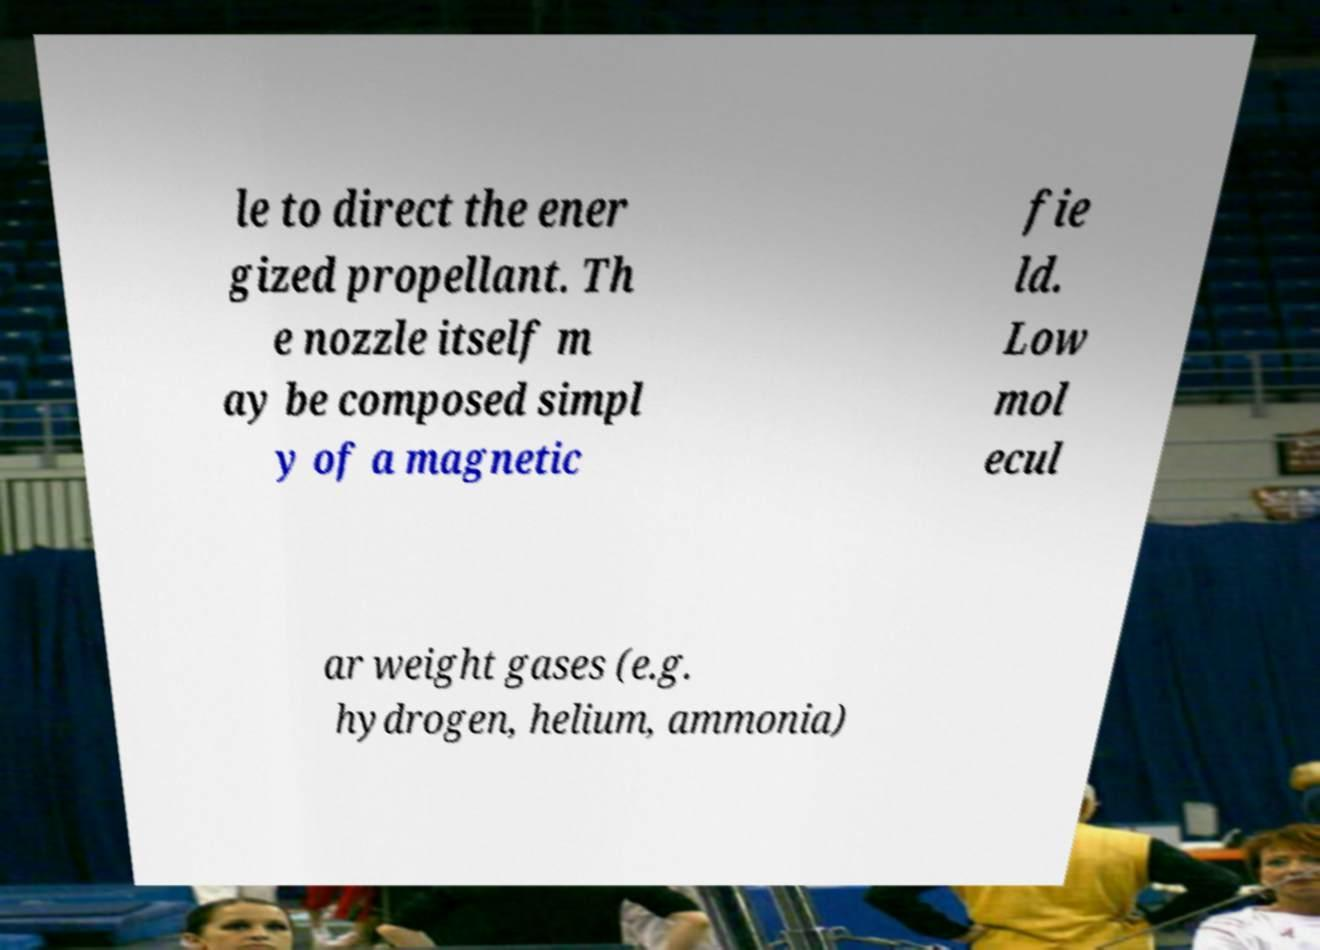For documentation purposes, I need the text within this image transcribed. Could you provide that? le to direct the ener gized propellant. Th e nozzle itself m ay be composed simpl y of a magnetic fie ld. Low mol ecul ar weight gases (e.g. hydrogen, helium, ammonia) 